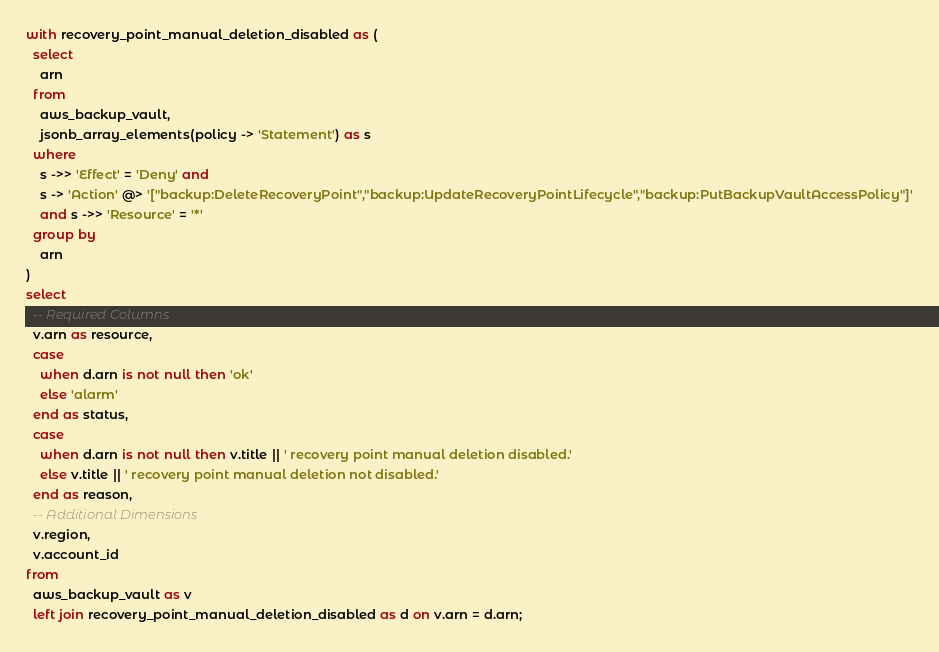Convert code to text. <code><loc_0><loc_0><loc_500><loc_500><_SQL_>with recovery_point_manual_deletion_disabled as (
  select
    arn
  from
    aws_backup_vault,
    jsonb_array_elements(policy -> 'Statement') as s
  where
    s ->> 'Effect' = 'Deny' and
    s -> 'Action' @> '["backup:DeleteRecoveryPoint","backup:UpdateRecoveryPointLifecycle","backup:PutBackupVaultAccessPolicy"]'
    and s ->> 'Resource' = '*'
  group by
    arn
)
select
  -- Required Columns
  v.arn as resource,
  case
    when d.arn is not null then 'ok'
    else 'alarm'
  end as status,
  case
    when d.arn is not null then v.title || ' recovery point manual deletion disabled.'
    else v.title || ' recovery point manual deletion not disabled.'
  end as reason,
  -- Additional Dimensions
  v.region,
  v.account_id
from
  aws_backup_vault as v
  left join recovery_point_manual_deletion_disabled as d on v.arn = d.arn;</code> 